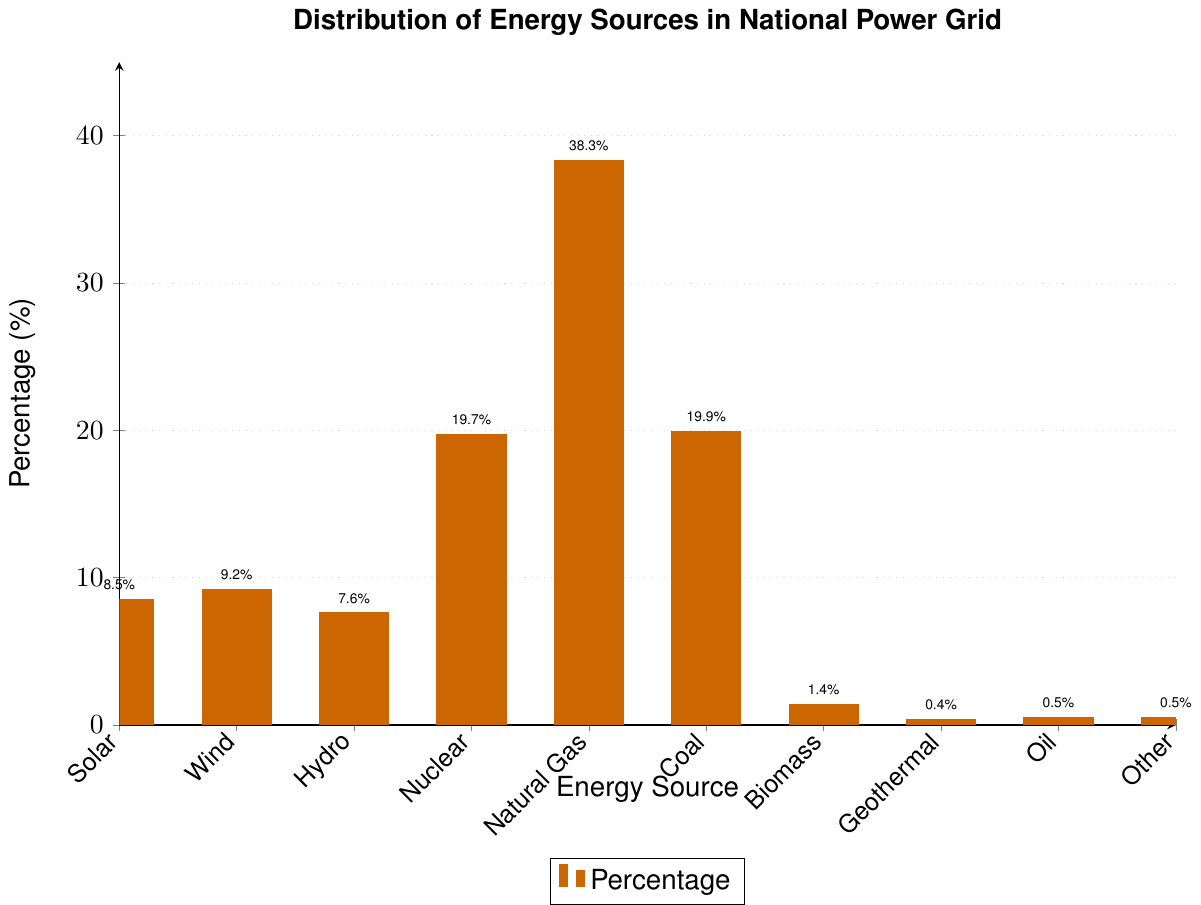Which energy source has the highest percentage in the national power grid? The highest bar in the chart corresponds to Natural Gas at 38.3%.
Answer: Natural Gas How does the percentage of nuclear energy compare with the percentage of coal energy? The percentages of nuclear and coal are 19.7% and 19.9%, respectively. Coal has a slightly higher percentage than nuclear.
Answer: Coal is slightly higher What is the combined percentage of renewable energy sources (solar, wind, hydro, and biomass)? Add the percentages of solar (8.5%), wind (9.2%), hydro (7.6%), and biomass (1.4%): 8.5 + 9.2 + 7.6 + 1.4 = 26.7%.
Answer: 26.7% If the energy sources with the lowest percentages (biomass, geothermal, oil, other) were to double, what would their total percentage be? Original percentages: biomass (1.4%), geothermal (0.4%), oil (0.5%), other (0.5%). Double each: 1.4 * 2 + 0.4 * 2 + 0.5 * 2 + 0.5 * 2 = 2.8 + 0.8 + 1 + 1 = 5.6%.
Answer: 5.6% What is the difference between the percentages of natural gas and solar energy? Subtract the percentage of solar energy (8.5%) from natural gas (38.3%): 38.3 - 8.5 = 29.8%.
Answer: 29.8% Which has a greater percentage: wind energy or hydro energy? Wind energy is 9.2% and hydro energy is 7.6%, so wind energy has a greater percentage.
Answer: Wind energy What is the average percentage of nuclear and coal energy sources? Add the percentages of nuclear (19.7%) and coal (19.9%) and divide by 2: (19.7 + 19.9) / 2 = 19.8%.
Answer: 19.8% Order the following energy sources from highest to lowest by their percentages: oil, biomass, geothermal, other. The percentages are: biomass (1.4%), oil (0.5%), geothermal (0.4%), other (0.5%). Ordered from highest to lowest: biomass, oil & other, geothermal.
Answer: Biomass, oil & other, geothermal What is the percentage difference between the largest non-renewable energy source and the largest renewable energy source? The largest non-renewable energy source is natural gas (38.3%) and the largest renewable energy source is wind (9.2%). The difference is 38.3 - 9.2 = 29.1%.
Answer: 29.1% Which bar is shown in green? The chart specifies that hydro is represented by green color.
Answer: Hydro 